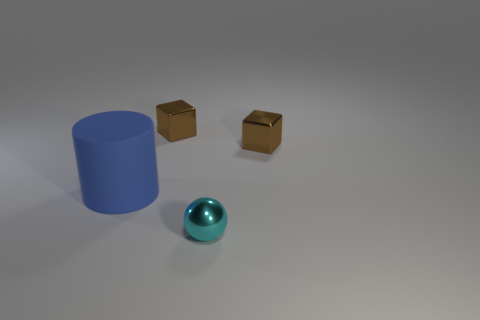Add 4 large red metal objects. How many objects exist? 8 Subtract all balls. How many objects are left? 3 Add 1 matte objects. How many matte objects exist? 2 Subtract 0 yellow cubes. How many objects are left? 4 Subtract all big cyan cylinders. Subtract all small metallic balls. How many objects are left? 3 Add 1 shiny cubes. How many shiny cubes are left? 3 